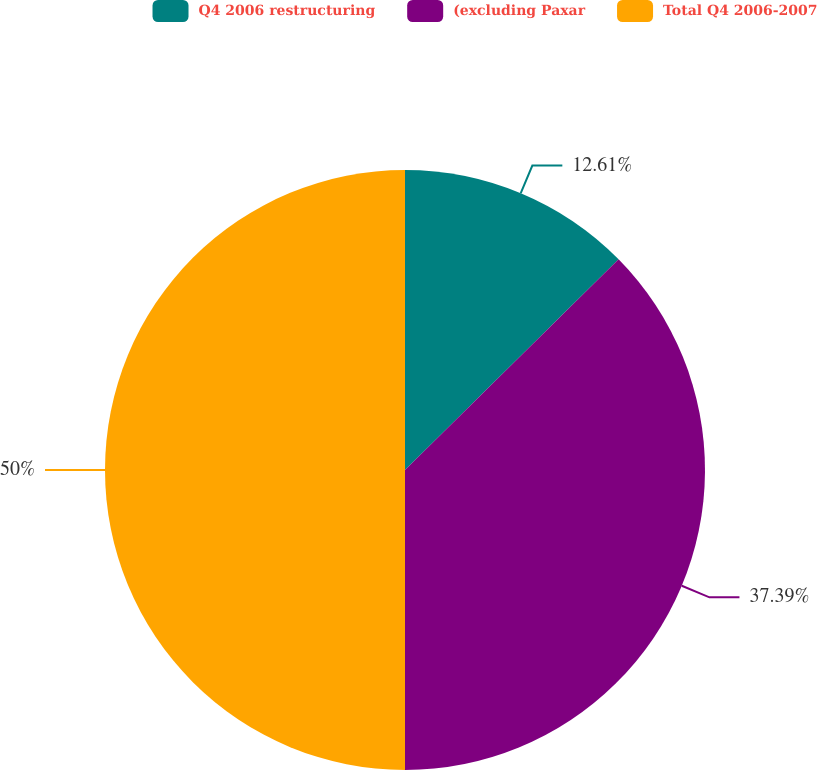Convert chart to OTSL. <chart><loc_0><loc_0><loc_500><loc_500><pie_chart><fcel>Q4 2006 restructuring<fcel>(excluding Paxar<fcel>Total Q4 2006-2007<nl><fcel>12.61%<fcel>37.39%<fcel>50.0%<nl></chart> 